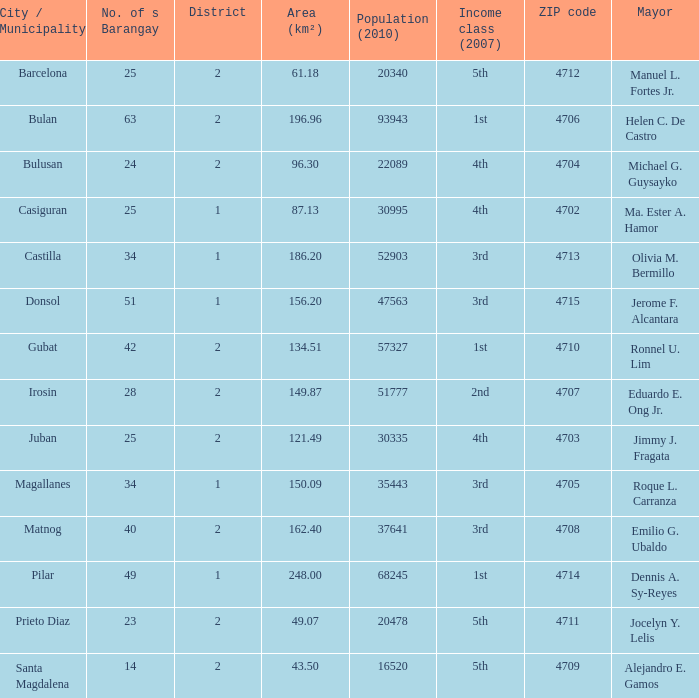What is the total quantity of populace (2010) where location (km²) is 134.51 1.0. Give me the full table as a dictionary. {'header': ['City / Municipality', 'No. of s Barangay', 'District', 'Area (km²)', 'Population (2010)', 'Income class (2007)', 'ZIP code', 'Mayor'], 'rows': [['Barcelona', '25', '2', '61.18', '20340', '5th', '4712', 'Manuel L. Fortes Jr.'], ['Bulan', '63', '2', '196.96', '93943', '1st', '4706', 'Helen C. De Castro'], ['Bulusan', '24', '2', '96.30', '22089', '4th', '4704', 'Michael G. Guysayko'], ['Casiguran', '25', '1', '87.13', '30995', '4th', '4702', 'Ma. Ester A. Hamor'], ['Castilla', '34', '1', '186.20', '52903', '3rd', '4713', 'Olivia M. Bermillo'], ['Donsol', '51', '1', '156.20', '47563', '3rd', '4715', 'Jerome F. Alcantara'], ['Gubat', '42', '2', '134.51', '57327', '1st', '4710', 'Ronnel U. Lim'], ['Irosin', '28', '2', '149.87', '51777', '2nd', '4707', 'Eduardo E. Ong Jr.'], ['Juban', '25', '2', '121.49', '30335', '4th', '4703', 'Jimmy J. Fragata'], ['Magallanes', '34', '1', '150.09', '35443', '3rd', '4705', 'Roque L. Carranza'], ['Matnog', '40', '2', '162.40', '37641', '3rd', '4708', 'Emilio G. Ubaldo'], ['Pilar', '49', '1', '248.00', '68245', '1st', '4714', 'Dennis A. Sy-Reyes'], ['Prieto Diaz', '23', '2', '49.07', '20478', '5th', '4711', 'Jocelyn Y. Lelis'], ['Santa Magdalena', '14', '2', '43.50', '16520', '5th', '4709', 'Alejandro E. Gamos']]} 